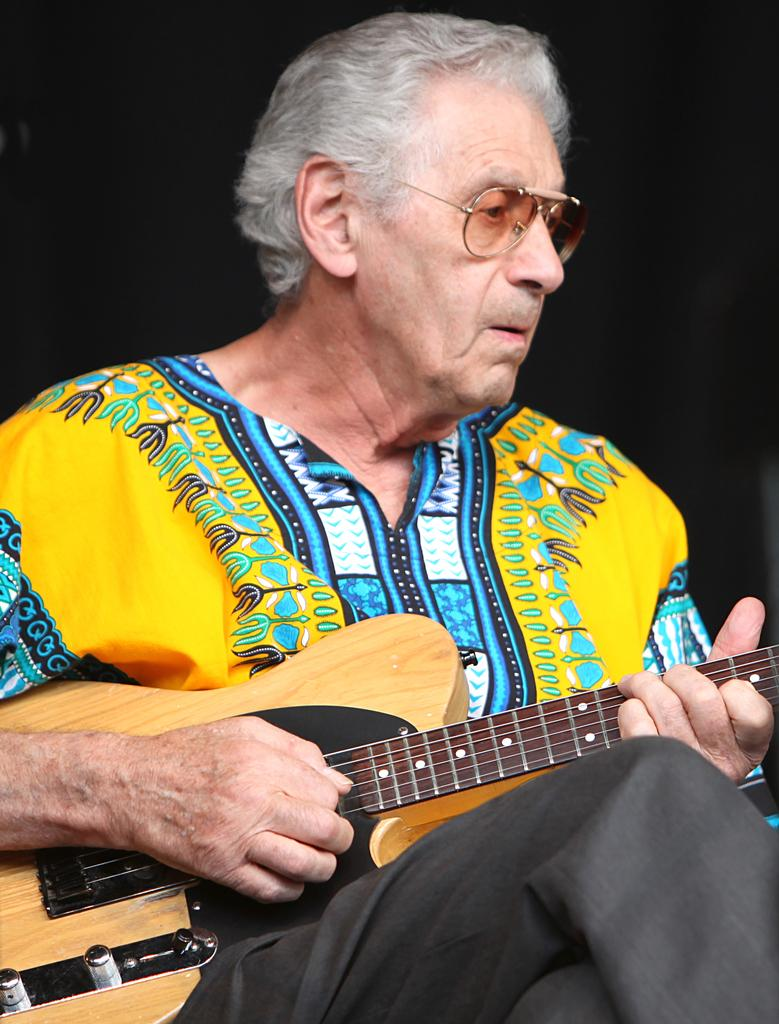Who is the main subject in the image? The main subject in the image is an old man. What is the old man wearing? The old man is wearing a yellow shirt and goggles. What is the old man doing in the image? The old man is sitting and playing a guitar. What is the color of the background in the image? The background of the image is dark. What type of wine is the old man drinking in the image? There is no wine present in the image; the old man is playing a guitar. Who is the owner of the guitar in the image? The question of ownership is not mentioned or implied in the image, so it cannot be determined. 